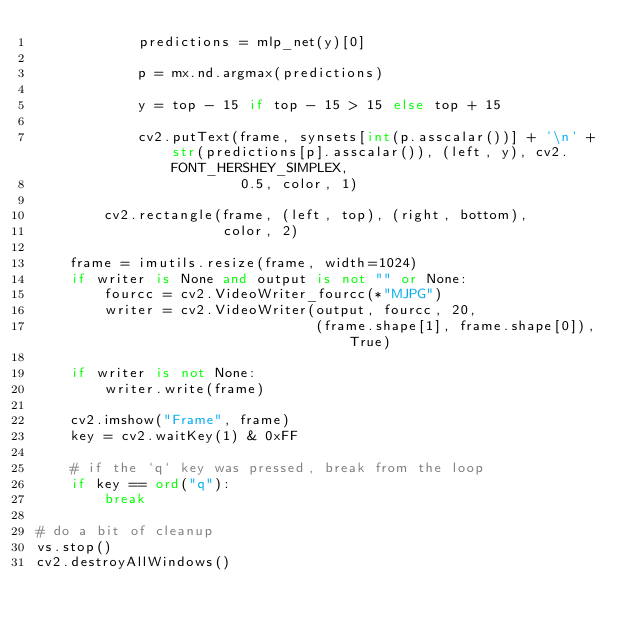Convert code to text. <code><loc_0><loc_0><loc_500><loc_500><_Python_>            predictions = mlp_net(y)[0]

            p = mx.nd.argmax(predictions)

            y = top - 15 if top - 15 > 15 else top + 15
            
            cv2.putText(frame, synsets[int(p.asscalar())] + '\n' + str(predictions[p].asscalar()), (left, y), cv2.FONT_HERSHEY_SIMPLEX,
                        0.5, color, 1)

        cv2.rectangle(frame, (left, top), (right, bottom),
                      color, 2)

    frame = imutils.resize(frame, width=1024)
    if writer is None and output is not "" or None:
        fourcc = cv2.VideoWriter_fourcc(*"MJPG")
        writer = cv2.VideoWriter(output, fourcc, 20,
                                 (frame.shape[1], frame.shape[0]), True)

    if writer is not None:
        writer.write(frame)

    cv2.imshow("Frame", frame)
    key = cv2.waitKey(1) & 0xFF

    # if the `q` key was pressed, break from the loop
    if key == ord("q"):
        break

# do a bit of cleanup
vs.stop()
cv2.destroyAllWindows()
</code> 